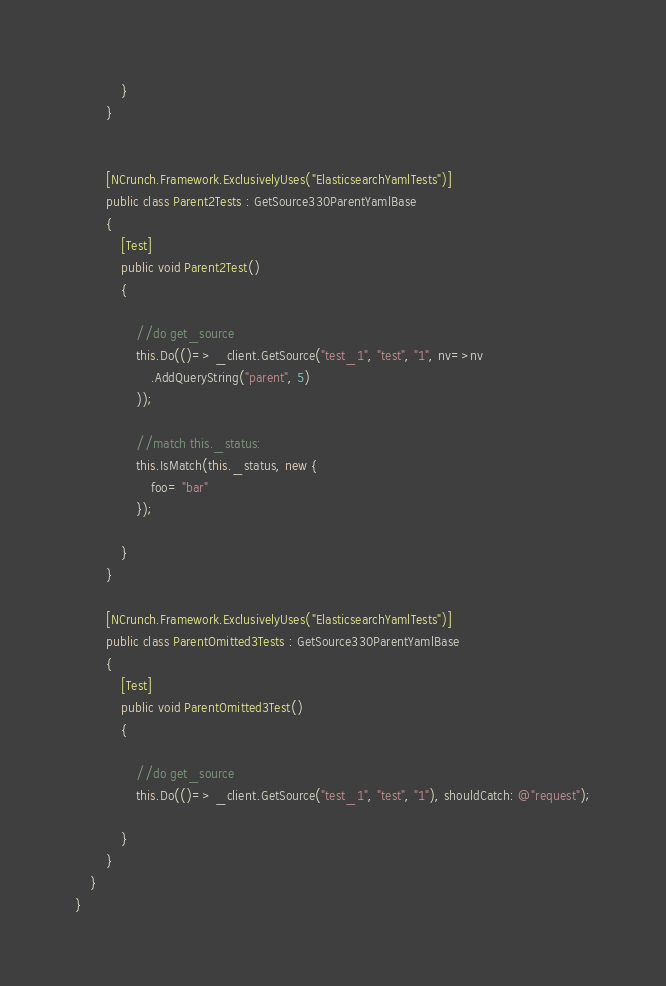Convert code to text. <code><loc_0><loc_0><loc_500><loc_500><_C#_>
			}
		}


		[NCrunch.Framework.ExclusivelyUses("ElasticsearchYamlTests")]
		public class Parent2Tests : GetSource330ParentYamlBase
		{
			[Test]
			public void Parent2Test()
			{	

				//do get_source 
				this.Do(()=> _client.GetSource("test_1", "test", "1", nv=>nv
					.AddQueryString("parent", 5)
				));

				//match this._status: 
				this.IsMatch(this._status, new {
					foo= "bar"
				});

			}
		}

		[NCrunch.Framework.ExclusivelyUses("ElasticsearchYamlTests")]
		public class ParentOmitted3Tests : GetSource330ParentYamlBase
		{
			[Test]
			public void ParentOmitted3Test()
			{	

				//do get_source 
				this.Do(()=> _client.GetSource("test_1", "test", "1"), shouldCatch: @"request");

			}
		}
	}
}

</code> 